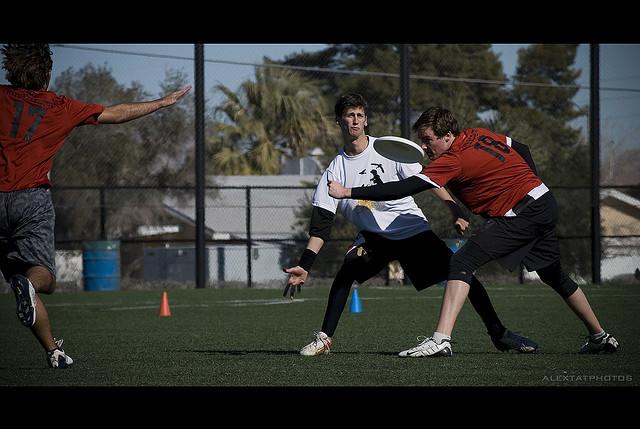How many orange cones do you see?
Answer briefly. 1. Are they playing tennis?
Quick response, please. No. Are there any garbage receptacles visible in this photo?
Be succinct. Yes. 